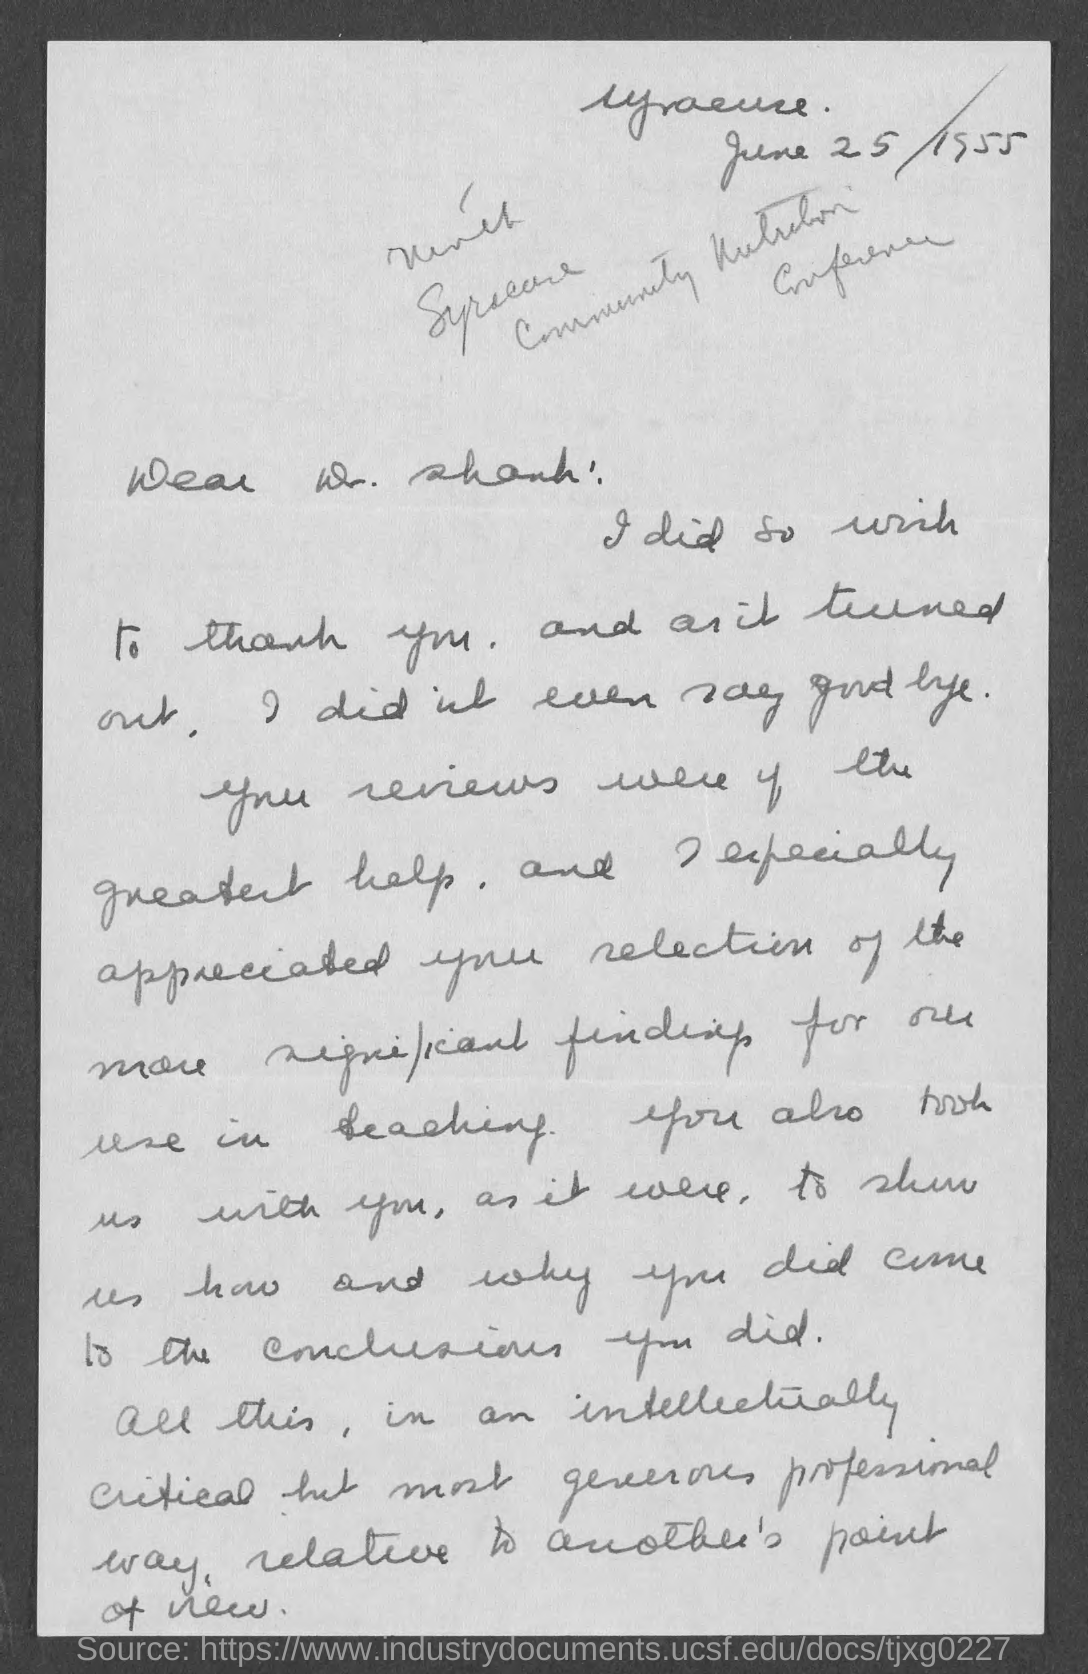Indicate a few pertinent items in this graphic. The letter is addressed to Dr. Shank. 